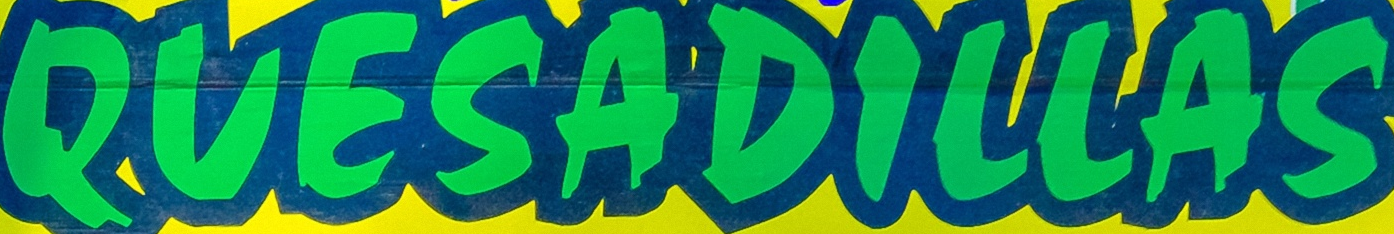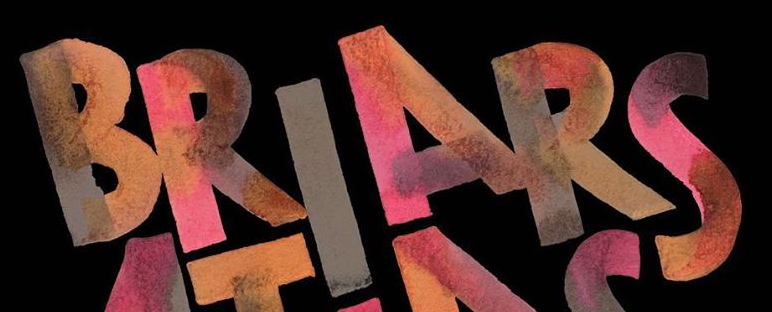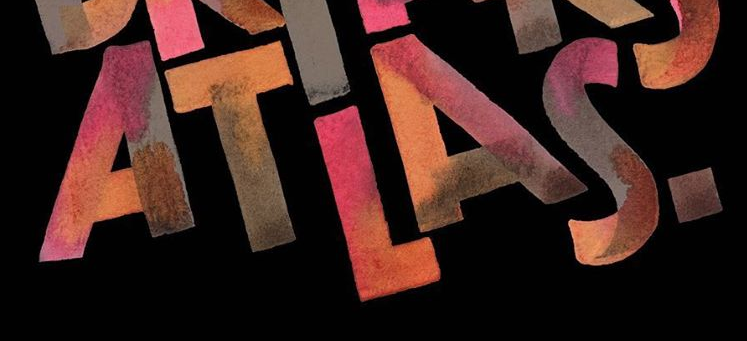Read the text from these images in sequence, separated by a semicolon. QUESADILLAS; BRIARS; ATLAS. 